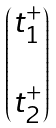<formula> <loc_0><loc_0><loc_500><loc_500>\begin{pmatrix} t ^ { + } _ { 1 } \\ \\ t ^ { + } _ { 2 } \end{pmatrix}</formula> 